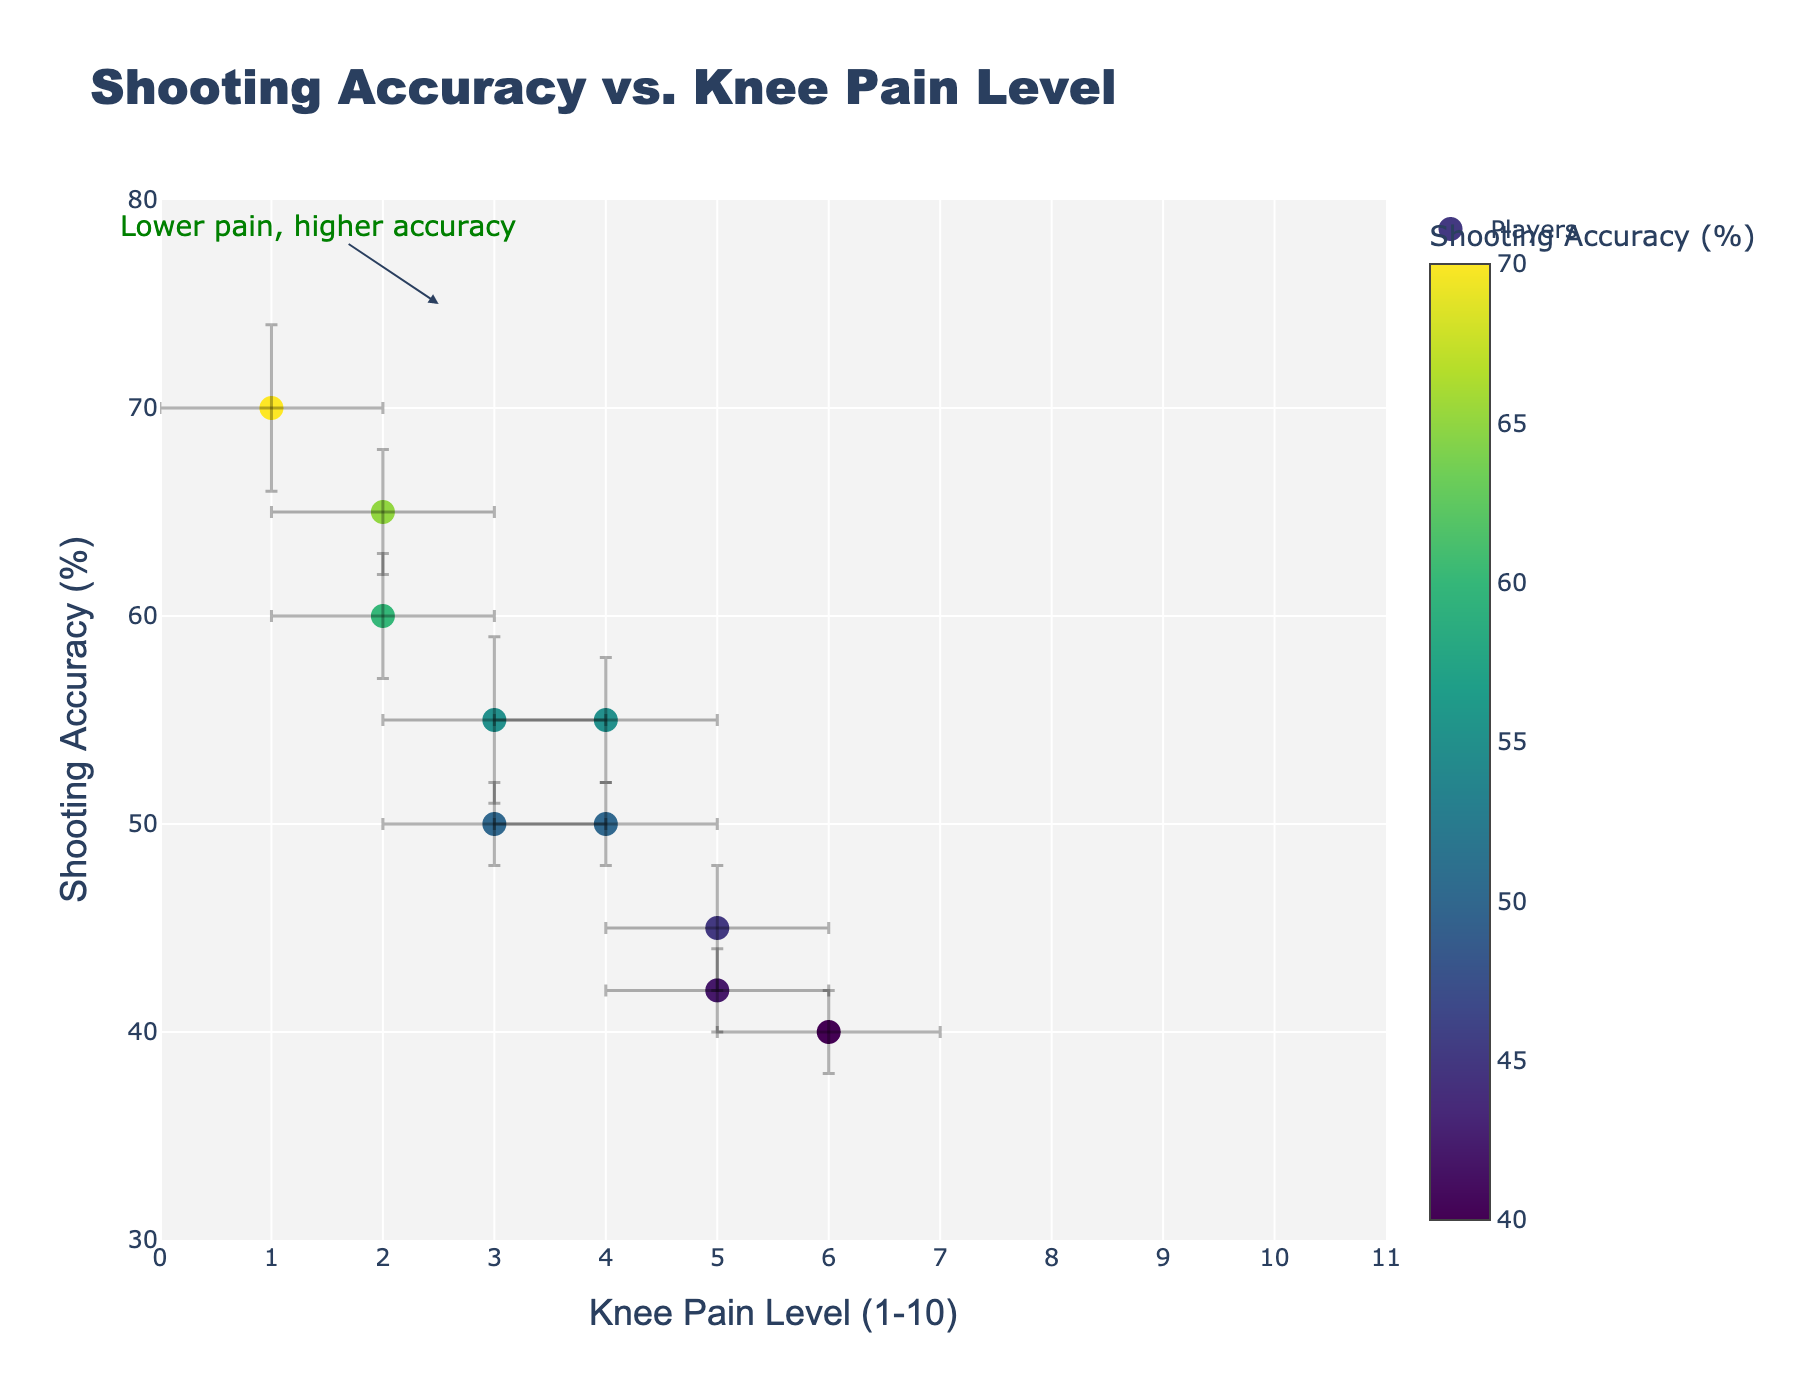What's the title of the scatter plot? The title of the scatter plot is located at the top of the figure.
Answer: Shooting Accuracy vs. Knee Pain Level How many data points are represented in the scatter plot? Each player's data constitutes one data point. Counting the number of players listed gives the total number of data points.
Answer: 10 Which player has the highest shooting accuracy? The player with the highest shooting accuracy is represented by the point highest on the y-axis.
Answer: James White What is the knee pain level for Alex Smith? The knee pain level for Alex Smith can be found by referring to his data point or using the hover information.
Answer: 6 Are there any players with a knee pain level of 1? If so, who are they? To find out, look at the points on the x-axis corresponding to a knee pain level of 1.
Answer: James White What is the average shooting accuracy for players with a knee pain level of 3? First, identify the points with a knee pain level of 3 (Mike Johnson, Jonathan Black), then calculate the average of their shooting accuracies ((55% + 50%) / 2).
Answer: 52.5% Who has a higher shooting accuracy: John Doe or Anthony Davis? Compare the y-axis values for John Doe and Anthony Davis.
Answer: John Doe What is the range of knee pain levels represented in the plot? The range of knee pain levels can be determined by looking at the smallest and largest values on the x-axis.
Answer: 1 to 6 Which player has the largest uncertainty in shooting accuracy? The player with the largest shooting accuracy error bars has the largest uncertainty.
Answer: Mike Johnson Is there a general trend or pattern shown in this plot between shooting accuracy and knee pain level? To determine the general trend, observe whether shooting accuracy increases, decreases, or stays the same as knee pain levels change.
Answer: Lower knee pain levels tend to be associated with higher shooting accuracy 